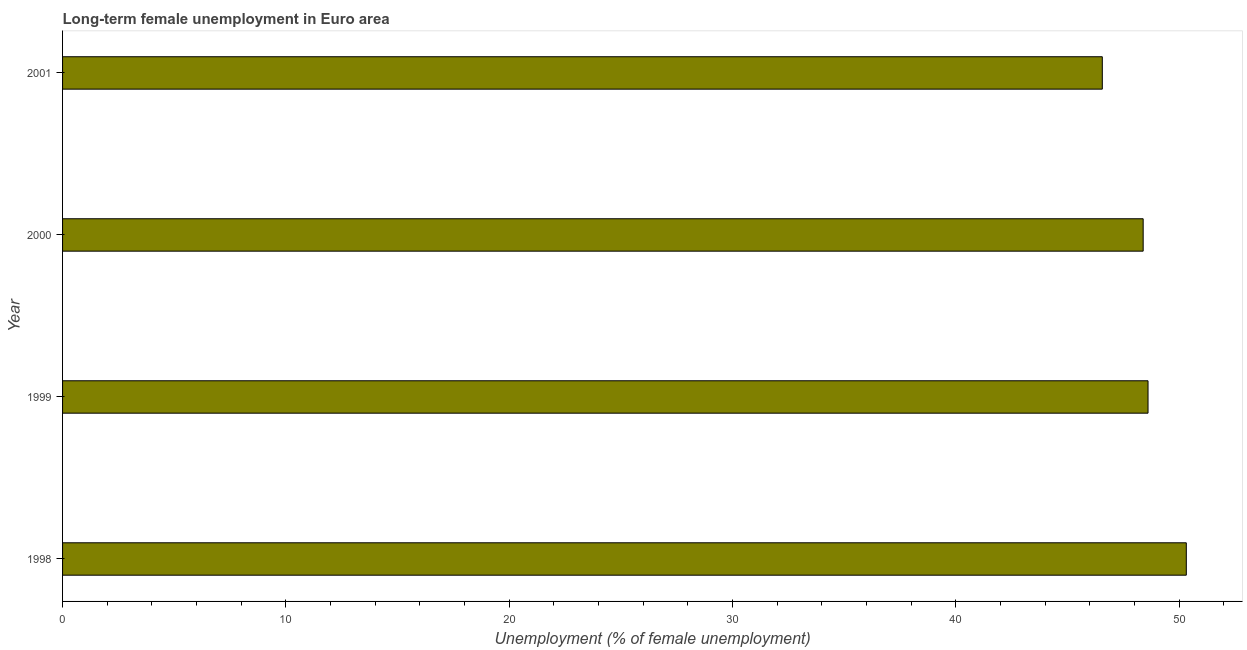Does the graph contain grids?
Keep it short and to the point. No. What is the title of the graph?
Offer a very short reply. Long-term female unemployment in Euro area. What is the label or title of the X-axis?
Your answer should be compact. Unemployment (% of female unemployment). What is the long-term female unemployment in 1998?
Give a very brief answer. 50.32. Across all years, what is the maximum long-term female unemployment?
Your answer should be compact. 50.32. Across all years, what is the minimum long-term female unemployment?
Your response must be concise. 46.56. What is the sum of the long-term female unemployment?
Provide a short and direct response. 193.87. What is the difference between the long-term female unemployment in 1998 and 2001?
Give a very brief answer. 3.76. What is the average long-term female unemployment per year?
Provide a short and direct response. 48.47. What is the median long-term female unemployment?
Your response must be concise. 48.5. Do a majority of the years between 1999 and 2001 (inclusive) have long-term female unemployment greater than 2 %?
Provide a succinct answer. Yes. What is the ratio of the long-term female unemployment in 1999 to that in 2001?
Provide a succinct answer. 1.04. Is the long-term female unemployment in 1999 less than that in 2000?
Ensure brevity in your answer.  No. Is the difference between the long-term female unemployment in 1998 and 1999 greater than the difference between any two years?
Your answer should be compact. No. What is the difference between the highest and the second highest long-term female unemployment?
Ensure brevity in your answer.  1.71. What is the difference between the highest and the lowest long-term female unemployment?
Your answer should be very brief. 3.76. In how many years, is the long-term female unemployment greater than the average long-term female unemployment taken over all years?
Offer a terse response. 2. How many bars are there?
Your answer should be very brief. 4. Are all the bars in the graph horizontal?
Offer a terse response. Yes. What is the difference between two consecutive major ticks on the X-axis?
Your answer should be compact. 10. What is the Unemployment (% of female unemployment) in 1998?
Offer a very short reply. 50.32. What is the Unemployment (% of female unemployment) in 1999?
Your answer should be compact. 48.61. What is the Unemployment (% of female unemployment) of 2000?
Offer a very short reply. 48.39. What is the Unemployment (% of female unemployment) in 2001?
Your answer should be very brief. 46.56. What is the difference between the Unemployment (% of female unemployment) in 1998 and 1999?
Offer a very short reply. 1.71. What is the difference between the Unemployment (% of female unemployment) in 1998 and 2000?
Your answer should be very brief. 1.93. What is the difference between the Unemployment (% of female unemployment) in 1998 and 2001?
Ensure brevity in your answer.  3.76. What is the difference between the Unemployment (% of female unemployment) in 1999 and 2000?
Provide a succinct answer. 0.22. What is the difference between the Unemployment (% of female unemployment) in 1999 and 2001?
Make the answer very short. 2.05. What is the difference between the Unemployment (% of female unemployment) in 2000 and 2001?
Make the answer very short. 1.83. What is the ratio of the Unemployment (% of female unemployment) in 1998 to that in 1999?
Provide a succinct answer. 1.03. What is the ratio of the Unemployment (% of female unemployment) in 1998 to that in 2001?
Provide a short and direct response. 1.08. What is the ratio of the Unemployment (% of female unemployment) in 1999 to that in 2001?
Provide a succinct answer. 1.04. What is the ratio of the Unemployment (% of female unemployment) in 2000 to that in 2001?
Offer a very short reply. 1.04. 